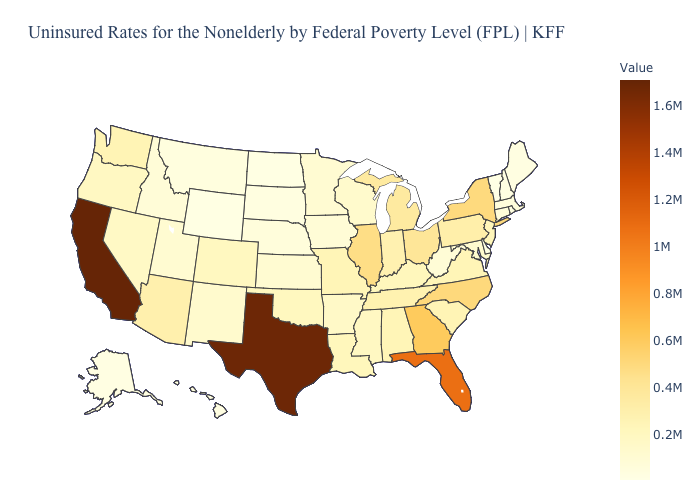Which states hav the highest value in the South?
Give a very brief answer. Texas. Which states have the lowest value in the USA?
Keep it brief. Vermont. Does Georgia have a higher value than Missouri?
Concise answer only. Yes. Among the states that border Wisconsin , does Illinois have the highest value?
Quick response, please. Yes. Which states hav the highest value in the West?
Give a very brief answer. California. Which states hav the highest value in the South?
Write a very short answer. Texas. Is the legend a continuous bar?
Write a very short answer. Yes. Does the map have missing data?
Concise answer only. No. 